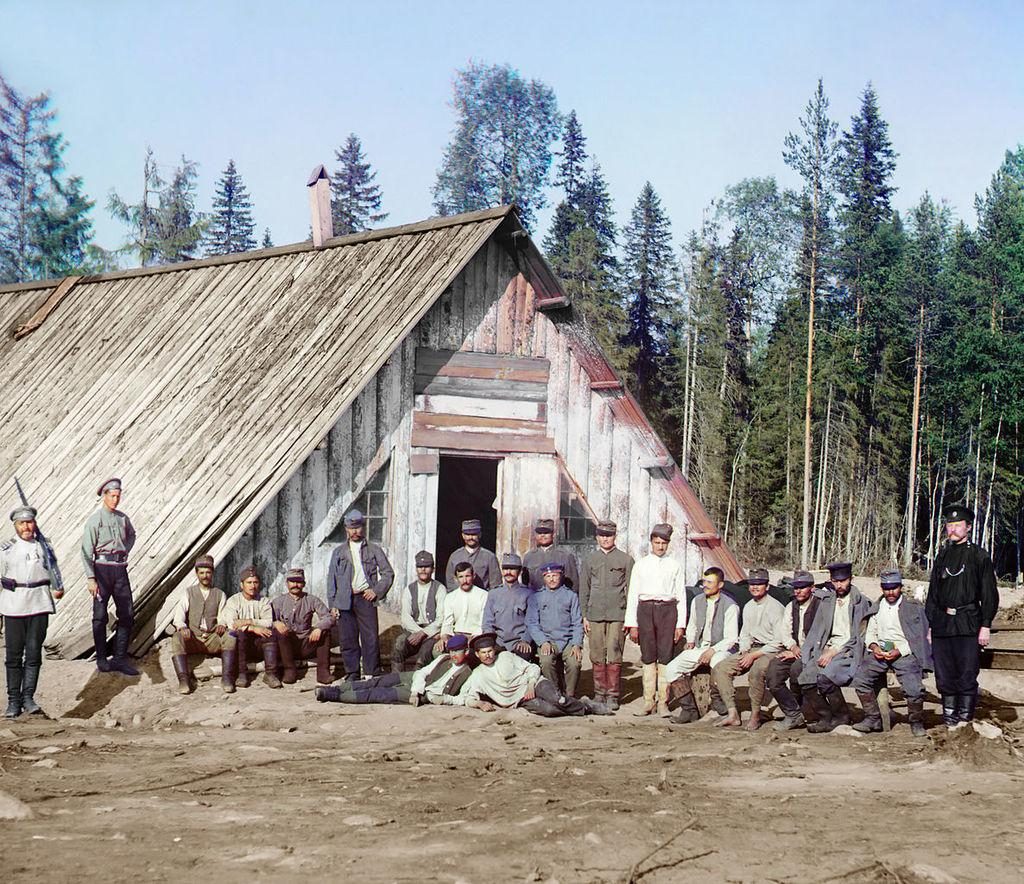What is the main structure in the center of the image? There is a shed in the center of the image. What are the people in the image doing? Some people are sitting, and some are standing in the image. What can be seen in the background of the image? There are trees and the sky visible in the background of the image. What type of wrench is being used by the person in the image? There is no wrench present in the image. Are the people in the image playing a game or engaging in any recreational activity? There is no indication of a game or recreational activity in the image; people are simply sitting and standing. 